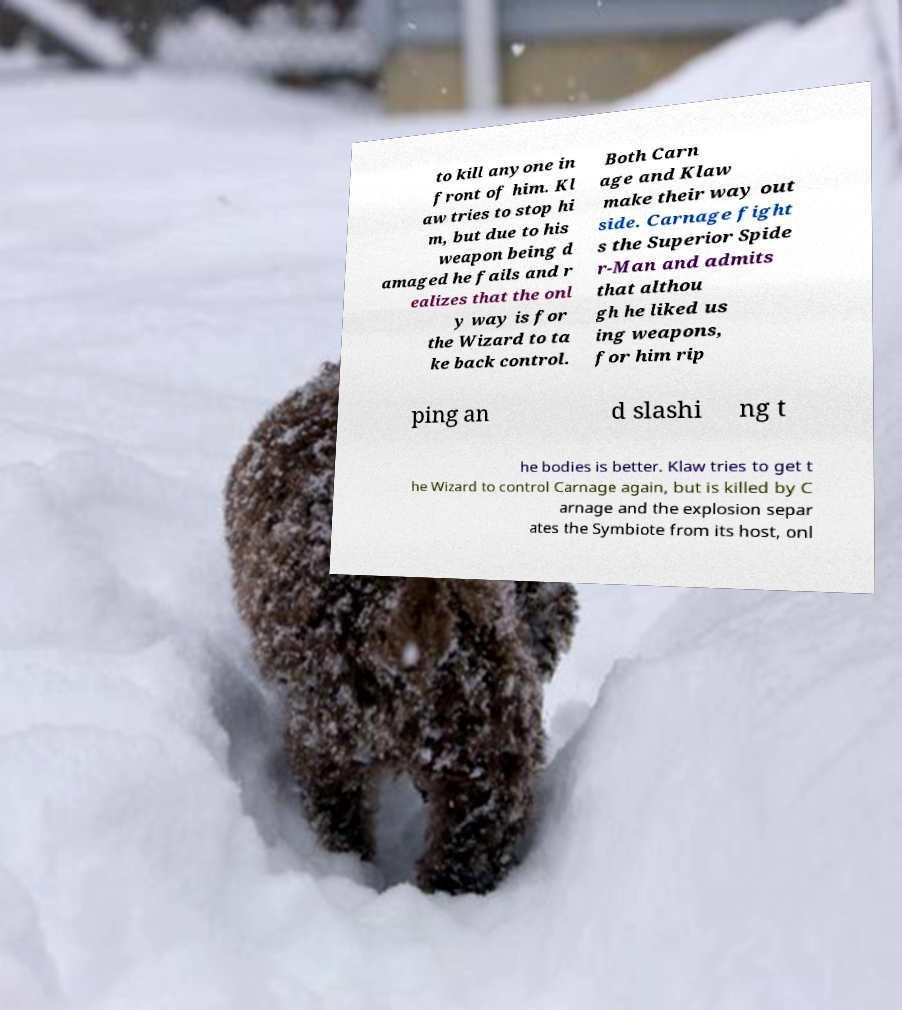What messages or text are displayed in this image? I need them in a readable, typed format. to kill anyone in front of him. Kl aw tries to stop hi m, but due to his weapon being d amaged he fails and r ealizes that the onl y way is for the Wizard to ta ke back control. Both Carn age and Klaw make their way out side. Carnage fight s the Superior Spide r-Man and admits that althou gh he liked us ing weapons, for him rip ping an d slashi ng t he bodies is better. Klaw tries to get t he Wizard to control Carnage again, but is killed by C arnage and the explosion separ ates the Symbiote from its host, onl 